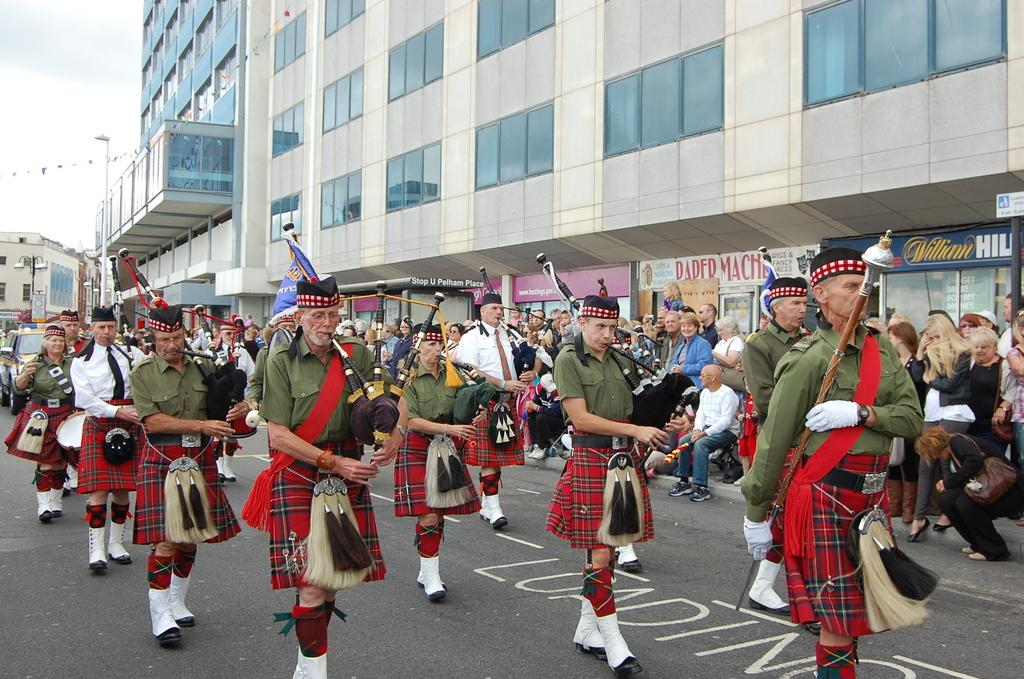What is the main structure in the middle of the image? There is a building in the middle of the image. What can be seen on the left side of the image? The sky is visible on the left side of the image. What are the people in the middle of the image doing? The people are walking and playing musical instruments. Where are the cows located in the image? There are no cows present in the image. What type of ball is being used by the dad in the image? There is no dad or ball present in the image. 